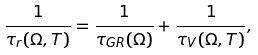Convert formula to latex. <formula><loc_0><loc_0><loc_500><loc_500>\frac { 1 } { \tau _ { r } ( \Omega , T ) } = \frac { 1 } { \tau _ { G R } ( \Omega ) } + \frac { 1 } { \tau _ { V } ( \Omega , T ) } ,</formula> 